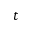Convert formula to latex. <formula><loc_0><loc_0><loc_500><loc_500>t</formula> 